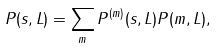Convert formula to latex. <formula><loc_0><loc_0><loc_500><loc_500>P ( s , L ) = \sum _ { m } P ^ { ( m ) } ( s , L ) P ( m , L ) ,</formula> 